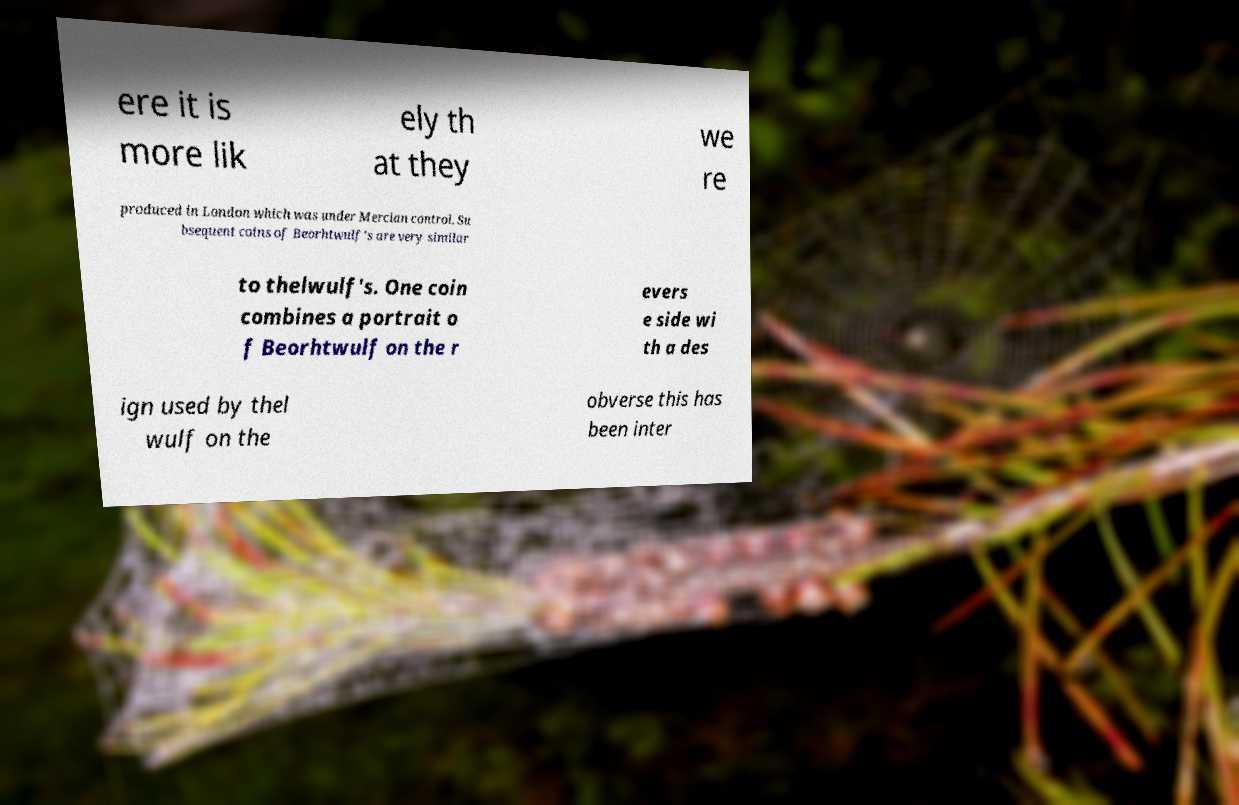Please identify and transcribe the text found in this image. ere it is more lik ely th at they we re produced in London which was under Mercian control. Su bsequent coins of Beorhtwulf's are very similar to thelwulf's. One coin combines a portrait o f Beorhtwulf on the r evers e side wi th a des ign used by thel wulf on the obverse this has been inter 